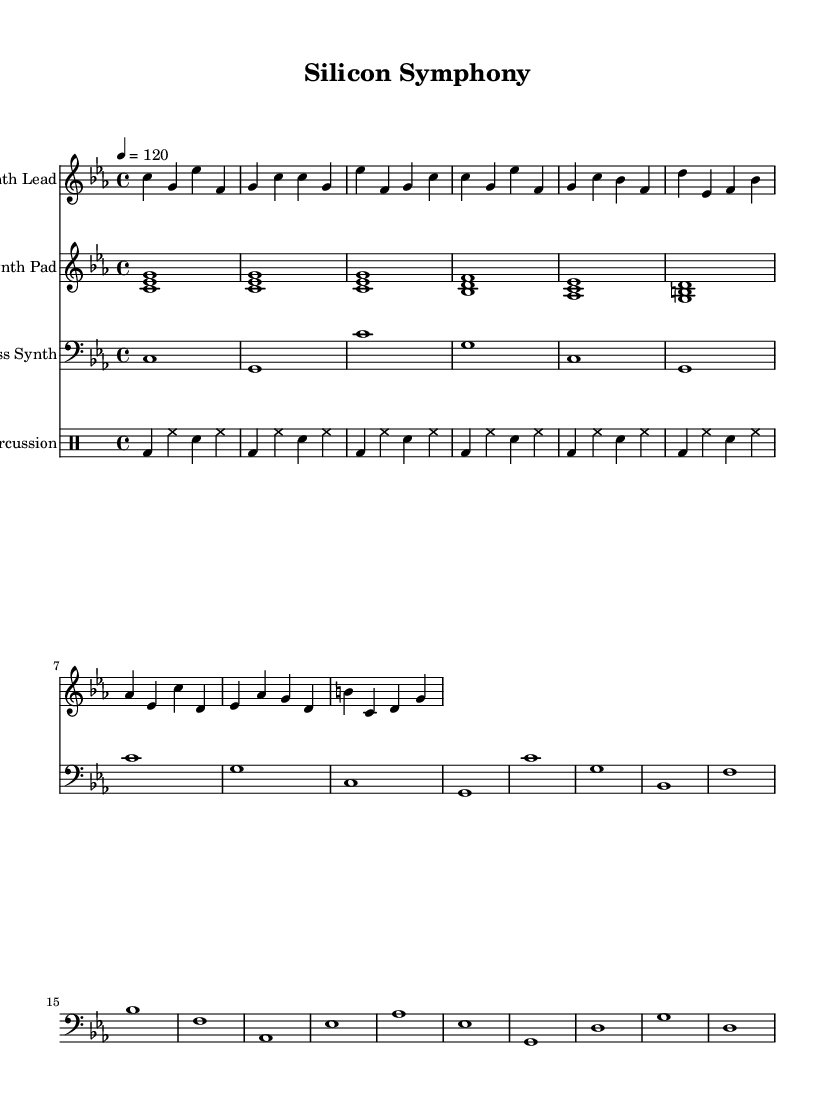What is the key signature of this music? The key signature is C minor, which is indicated by three flats: B-flat, E-flat, and A-flat.
Answer: C minor What is the time signature of this composition? The time signature is 4/4, indicated by the notation at the beginning of the score, which means there are four beats per measure.
Answer: 4/4 What is the tempo marking for this piece? The tempo marking is 120 beats per minute, indicated by "4 = 120" at the beginning of the score.
Answer: 120 How many measures are in the synth lead part? The synth lead part has a total of 6 measures, which can be counted from the notation in that staff.
Answer: 6 What is the instrument name for the first staff? The instrument name for the first staff is "Synth Lead," which is indicated at the start of that particular staff section.
Answer: Synth Lead Which instrument plays the bass line in this piece? The bass line is played by the "Bass Synth," as indicated by the relevant staff notation for that instrument.
Answer: Bass Synth What is the primary rhythmic element used in the percussion staff? The primary rhythmic element in the percussion staff is the bass drum and hi-hat combination, alternating throughout the measures, which is common in electronic music.
Answer: Bass drum and hi-hat 